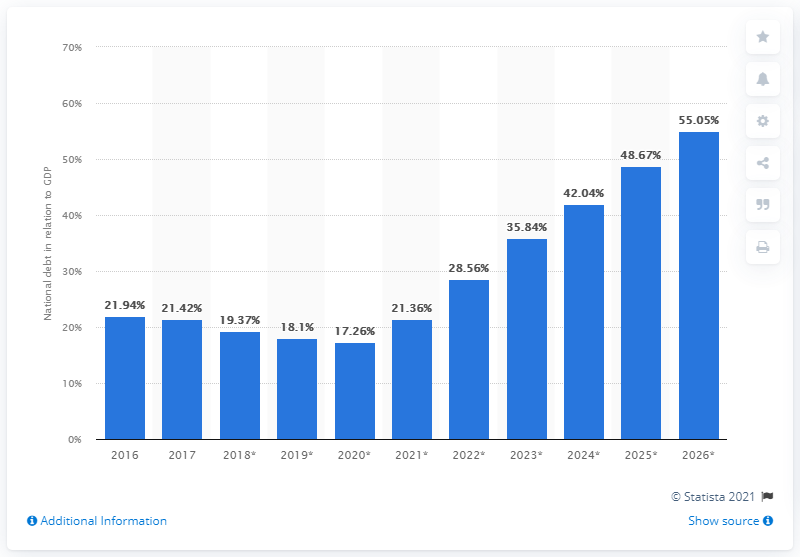Highlight a few significant elements in this photo. In 2017, the national debt of Kiribati was 21.36 billion dollars. 